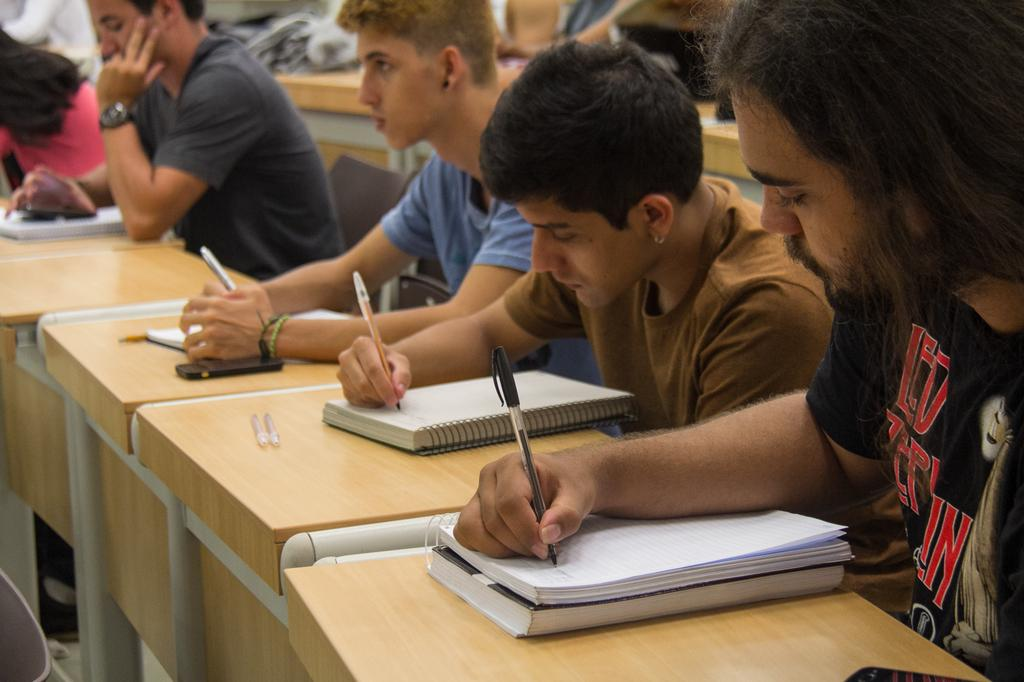<image>
Summarize the visual content of the image. A long haired fellow with a black Led Zeplin t-shirt takes notes in a class setting next to classmates. 